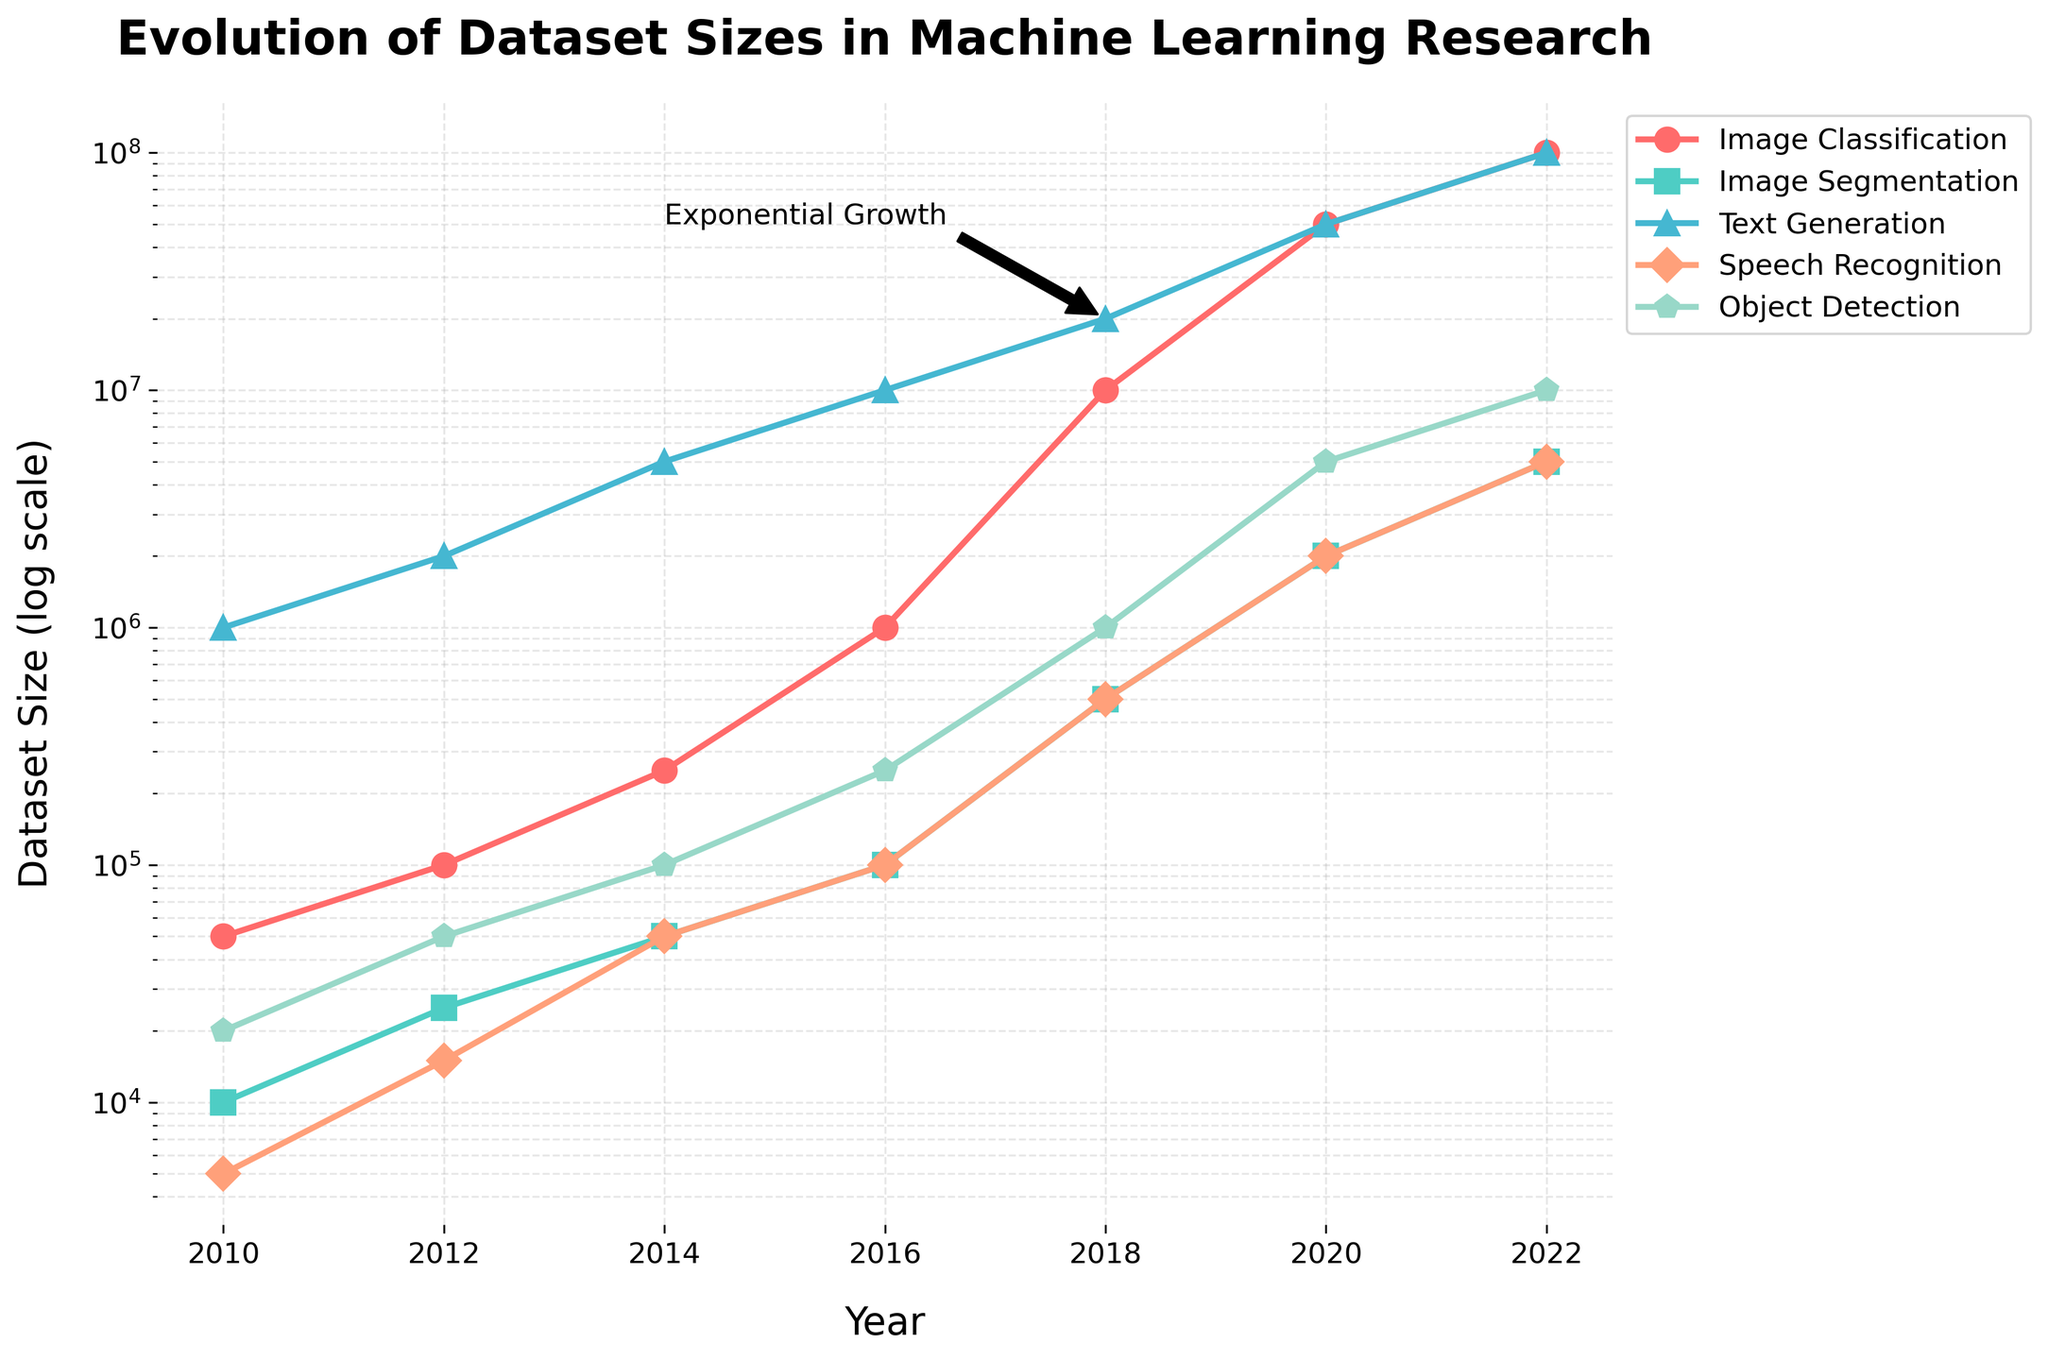What task type saw the most significant increase in dataset size between 2012 and 2014? Look at the vertical increases between 2012 and 2014 for all task types. Image Classification went from 100,000 to 250,000, Image Segmentation from 25,000 to 50,000, Text Generation from 2,000,000 to 5,000,000, Speech Recognition from 15,000 to 50,000, and Object Detection from 50,000 to 100,000. Thus, Text Generation saw the largest increase, going from 2,000,000 to 5,000,000.
Answer: Text Generation Which task type had the largest dataset size in 2022? Check the dataset sizes for all task types in the year 2022: Image Classification at 100,000,000, Image Segmentation at 5,000,000, Text Generation at 100,000,000, Speech Recognition at 5,000,000, and Object Detection at 10,000,000. The largest dataset sizes in 2022 are Image Classification and Text Generation, both at 100,000,000.
Answer: Image Classification and Text Generation What is the difference in dataset sizes for Image Segmentation between 2016 and 2022? Look at the dataset sizes for Image Segmentation in 2016 and 2022: for 2016, it is 100,000, and for 2022, it is 5,000,000. The difference is calculated as 5,000,000 - 100,000 = 4,900,000.
Answer: 4,900,000 Which years saw the dataset size for Speech Recognition increase by an order of magnitude? Examine the dataset sizes for Speech Recognition across all years: 2010 (5,000), 2012 (15,000), 2014 (50,000), 2016 (100,000), 2018 (500,000), 2020 (2,000,000), 2022 (5,000,000). Notice the increases are between 2010-2012, 2012-2014, 2016-2018, and 2018-2020. Specifically, 2014 to 2016 (50,000 to 100,000) shows an order of magnitude (10x) increase.
Answer: 2014 to 2016 Between 2010 and 2018, which task had the smallest overall growth in dataset size? Assess the differences: Image Classification (50,000 to 10,000,000), Image Segmentation (10,000 to 500,000), Text Generation (1,000,000 to 20,000,000), Speech Recognition (5,000 to 500,000), Object Detection (20,000 to 1,000,000). The smallest growth in absolute terms is for Image Segmentation from 10,000 to 500,000, which is an increase of 490,000.
Answer: Image Segmentation In what year do you observe the annotation 'Exponential Growth,' and which task(s) does it relate to? The annotation 'Exponential Growth' is marked around 2018 and points to the line representing Text Generation, suggesting an exponential increase around that point. The annotation text is placed relative to Text Generation data points.
Answer: 2018, Text Generation 